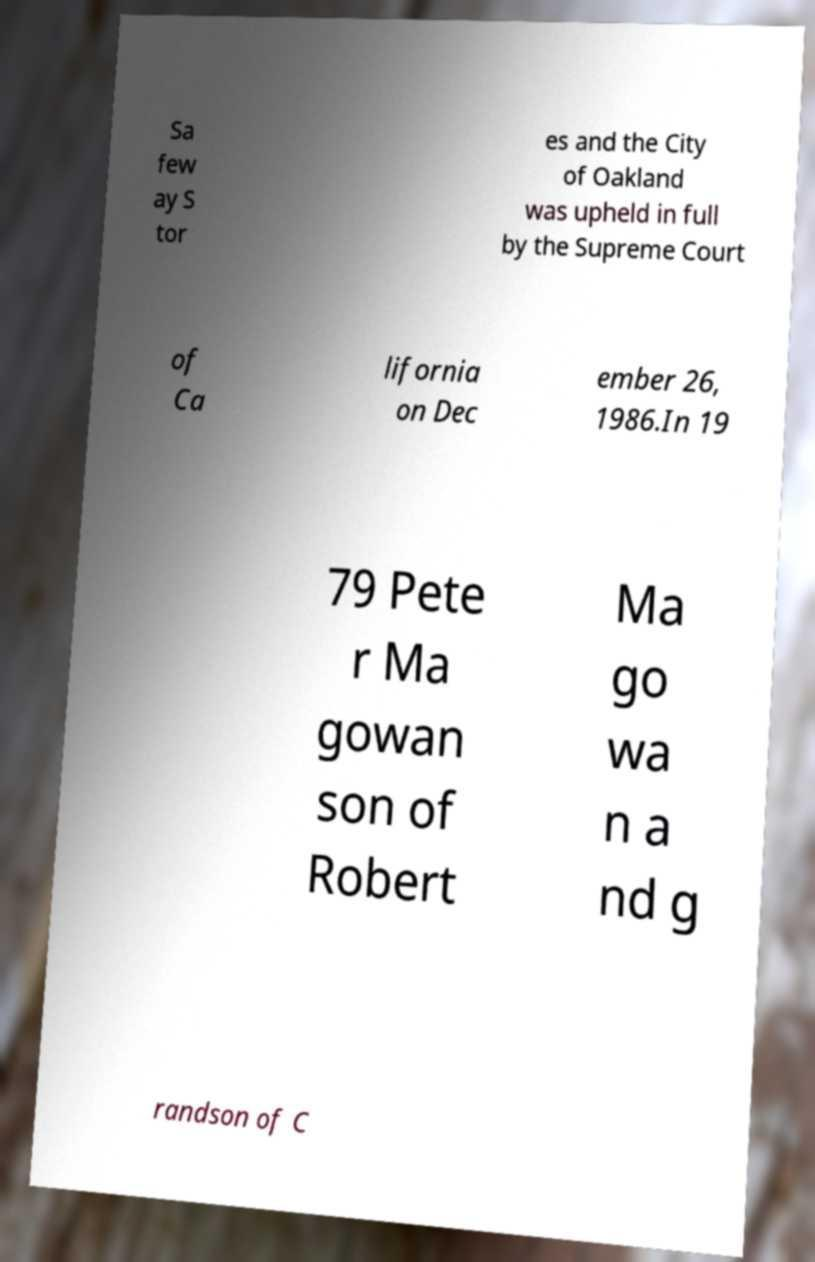For documentation purposes, I need the text within this image transcribed. Could you provide that? Sa few ay S tor es and the City of Oakland was upheld in full by the Supreme Court of Ca lifornia on Dec ember 26, 1986.In 19 79 Pete r Ma gowan son of Robert Ma go wa n a nd g randson of C 